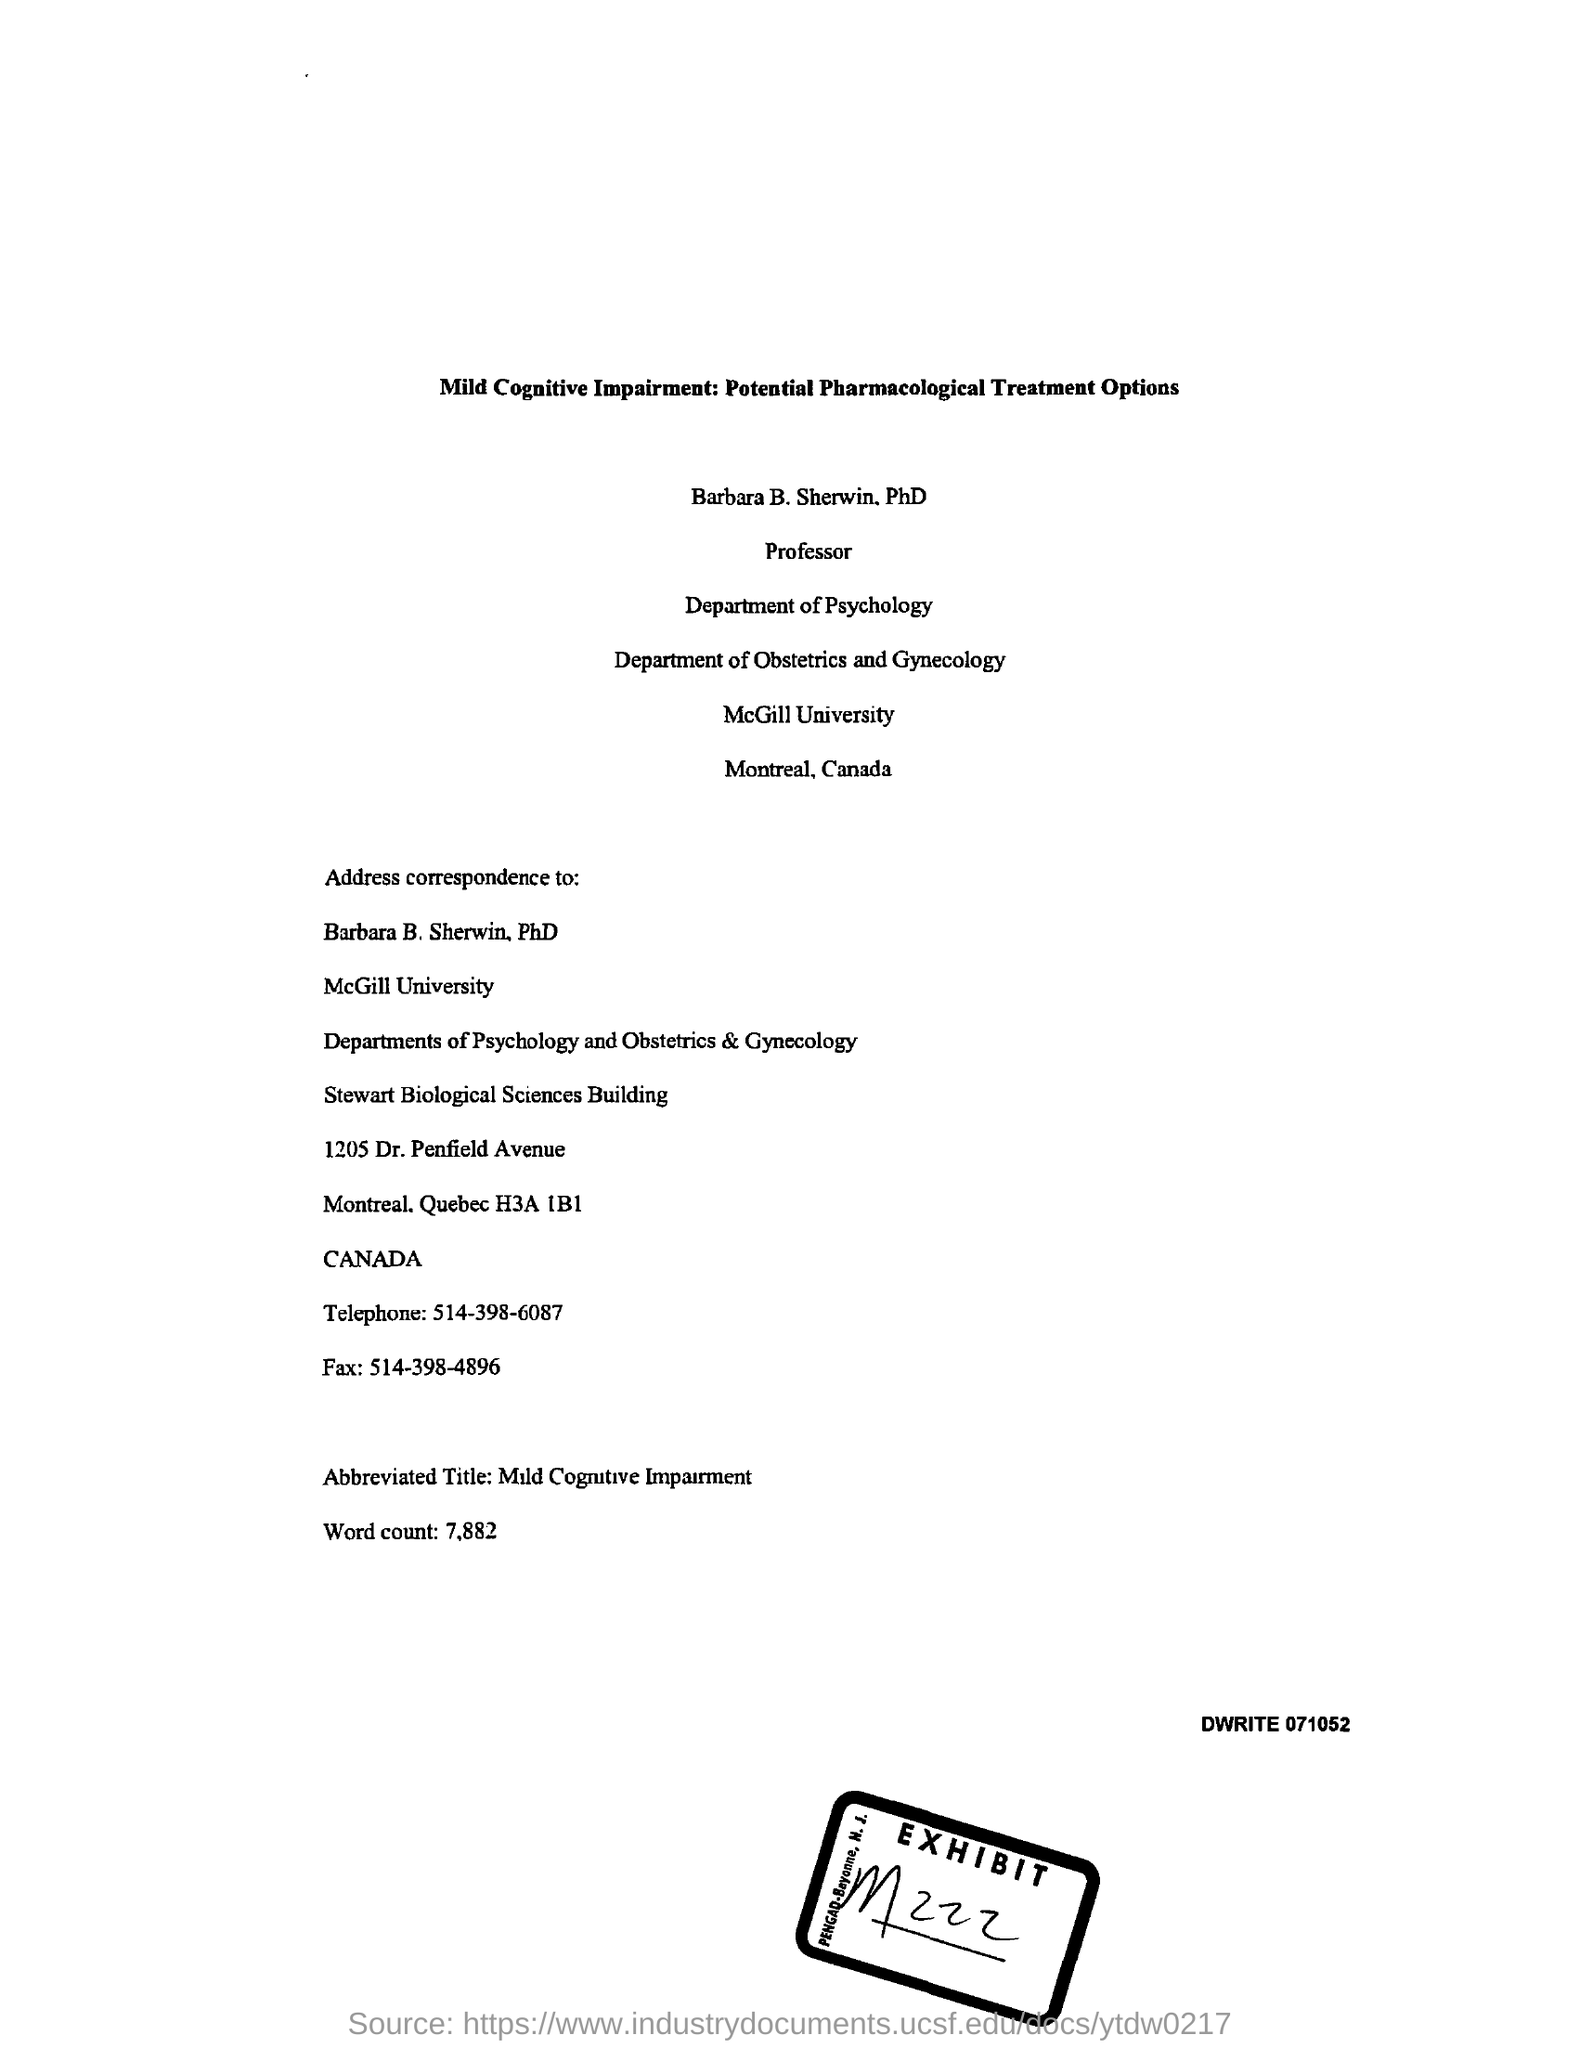Mention a couple of crucial points in this snapshot. The telephone number is 514-398-6087. The word count is 7,882. The abbreviated title of Mild Cognitive Impairment. The fax number is 514-398-4896. The exhibit number is M 222. 